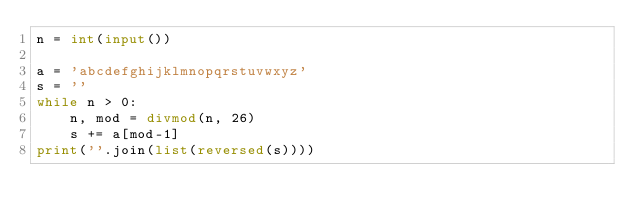Convert code to text. <code><loc_0><loc_0><loc_500><loc_500><_Python_>n = int(input())

a = 'abcdefghijklmnopqrstuvwxyz'
s = ''
while n > 0:
    n, mod = divmod(n, 26)
    s += a[mod-1]
print(''.join(list(reversed(s))))</code> 